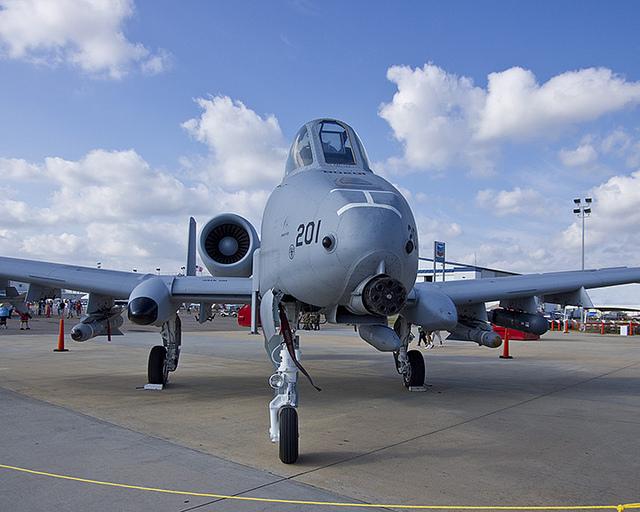Is the plane at a airport?
Answer briefly. Yes. What is the number on the plane?
Answer briefly. 201. Is there more than one plane visible?
Be succinct. No. 